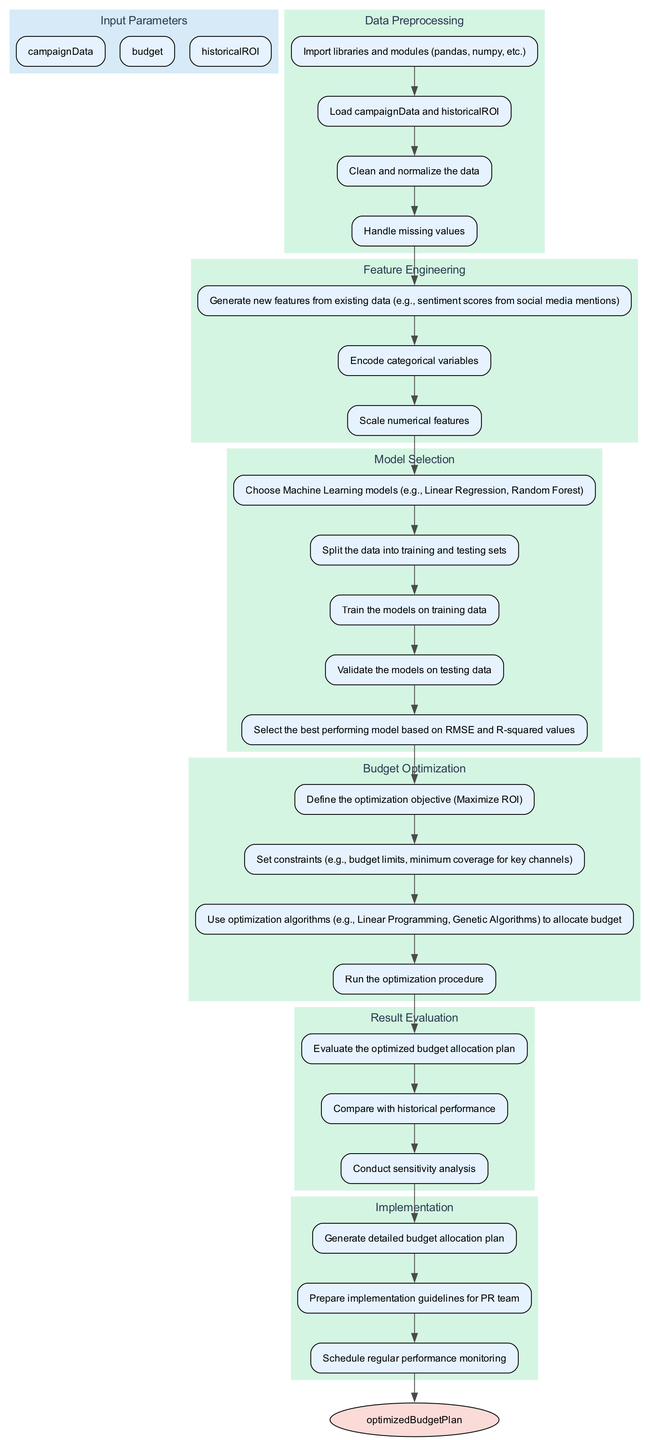What is the first step in the function? The first step listed under "Data Preprocessing" is "Import libraries and modules (pandas, numpy, etc.)". This is the initial action that sets up the environment for the rest of the function.
Answer: Import libraries and modules (pandas, numpy, etc.) How many elements are in the function? The diagram contains six main elements which are "Data Preprocessing", "Feature Engineering", "Model Selection", "Budget Optimization", "Result Evaluation", and "Implementation". This total count is derived from listing the main sections of the function.
Answer: 6 What is the optimization objective defined in the "Budget Optimization" step? According to the steps in the "Budget Optimization" element, the objective is to "Maximize ROI". This is a clear statement outlining the goal of this phase in the function.
Answer: Maximize ROI Which step follows "Train the models on training data" in "Model Selection"? In the "Model Selection" section, the step that follows "Train the models on training data" is "Validate the models on testing data". This indicates the flow of actions during model selection.
Answer: Validate the models on testing data What is the last step in the flowchart? The flowchart concludes with the step "Schedule regular performance monitoring" under the "Implementation" section. This indicates that ongoing evaluation is part of the final output.
Answer: Schedule regular performance monitoring Which optimization algorithms can be used in the function? The "Budget Optimization" element lists two specific types of optimization algorithms: "Linear Programming" and "Genetic Algorithms". These represent the methods that may be employed to achieve budget allocation.
Answer: Linear Programming, Genetic Algorithms What is compared with historical performance in "Result Evaluation"? The step in "Result Evaluation" that involves comparison states "Compare with historical performance", indicating that the optimized budget plan is assessed against past outcomes to evaluate effectiveness.
Answer: Compare with historical performance Which element includes "Generate new features from existing data"? This particular step is located in the "Feature Engineering" section. It describes the process of creating additional relevant data points that can enhance model training.
Answer: Feature Engineering How does "Model Selection" connect to "Budget Optimization"? There is a direct connection where the last step of "Model Selection", which is evaluating and selecting the best model, feeds into the first step of "Budget Optimization". This reflects the flow of information from model assessment to budget allocation.
Answer: Evaluating and selecting the best model feeds into budget allocation 